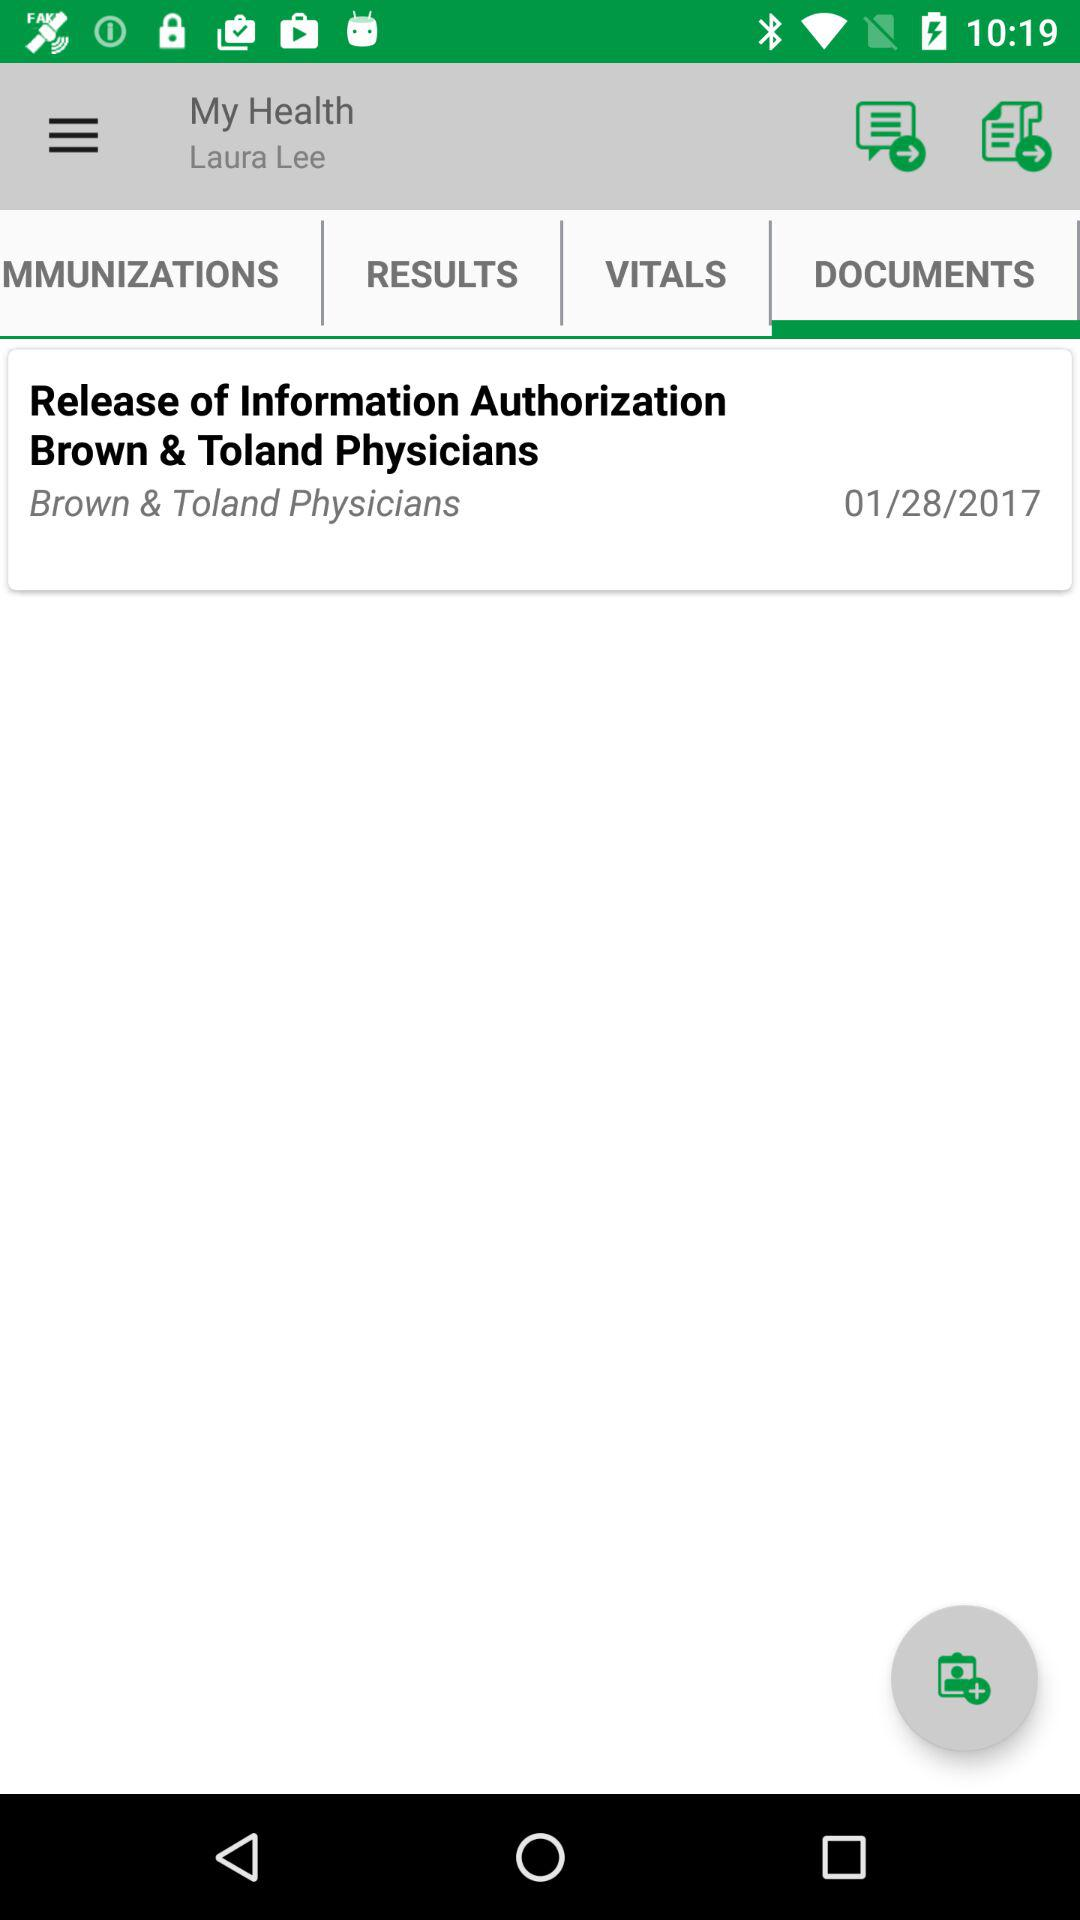What's the publication date of the document? The date of publication is January 28, 2017. 